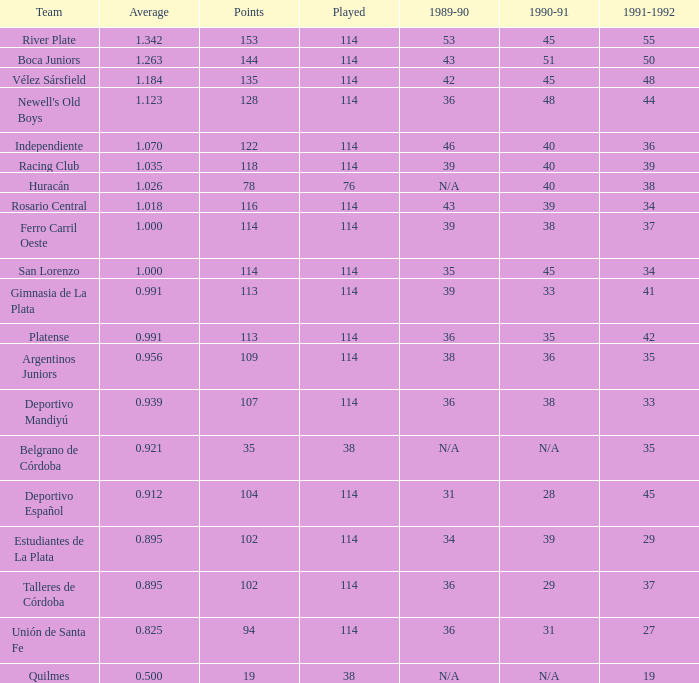How much Played has an Average smaller than 0.9390000000000001, and a 1990-91 of 28? 1.0. 